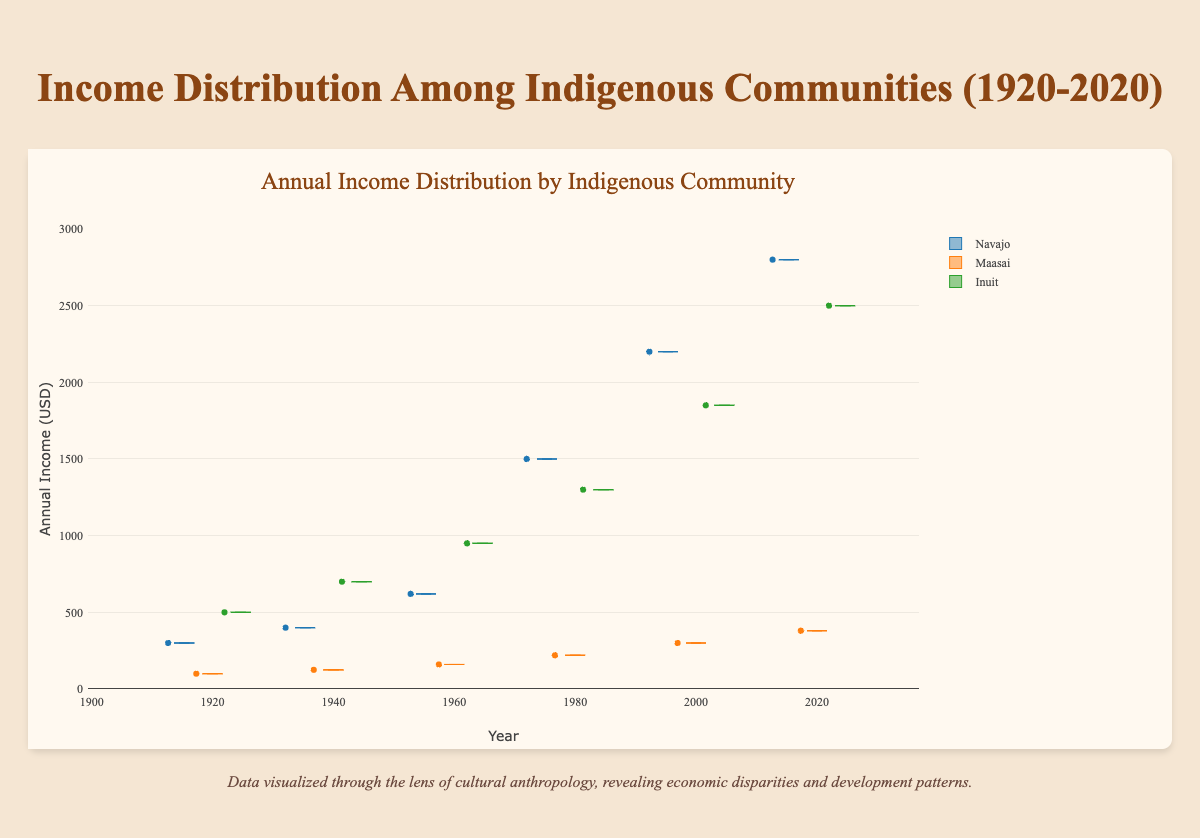What is the range of the annual income for the Navajo community in 1920? From the figure, look for the minimum and maximum values of the Navajo community's box plot for the year 1920. The range is the difference between these two values.
Answer: 300 Which indigenous community showed the highest annual income in 2020? Compare the data points for the year 2020 across the three communities (Navajo, Maasai, and Inuit). Pick the highest income value among them.
Answer: Navajo Between 1980 and 2000, which community experienced the greatest increase in annual income? Calculate the difference in annual income for each community between 1980 and 2000. Compare these differences and identify the largest one. Navajo: 2200-1500=700, Maasai: 300-220=80, Inuit: 1850-1300=550.
Answer: Navajo What is the approximate median income for the Inuit community in 1960? Look at the box plot for the Inuit community in 1960 and identify the median value, which is the line inside the box.
Answer: 950 How does the income distribution for the Navajo community in 2020 compare to the Maasai community in the same year? Compare the heights of the box plots for both communities in the year 2020. The Navajo community has higher values.
Answer: Navajo is higher Which community shows the least variability in their annual income over the years? Examine the lengths of the box plots for each community; the one with consistently smaller boxes over the years indicates less variability.
Answer: Maasai By how much did the annual income of the Maasai community increase from 1920 to 2020? Subtract the 1920 value from the 2020 value for the Maasai community. 380 - 100 = 280.
Answer: 280 What trends can be observed in the annual income of indigenous communities over the past century? Look at the overall direction and magnitude of change in each community's income over the years. Generally, all communities show an increasing trend.
Answer: Increasing trend Which year shows the most significant income disparity among the communities? Compare the income values for all three communities year by year and determine which year has the widest spread between the highest and lowest incomes.
Answer: 2020 Are there any outliers in the annual income data for any community? Check for individual data points that fall significantly outside the range of the box plots for any community in any year.
Answer: None visible 